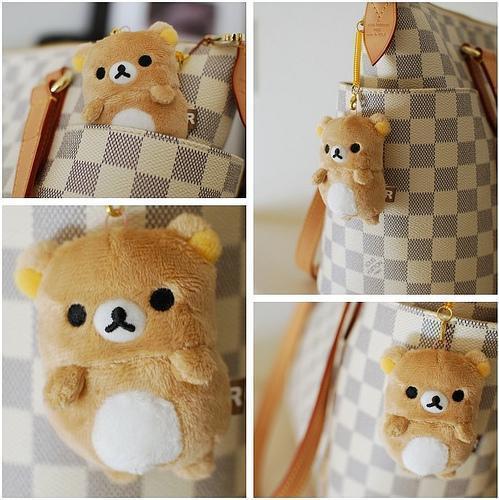How many pictures are joined?
Give a very brief answer. 4. How many teddy bears are there?
Give a very brief answer. 4. How many handbags are visible?
Give a very brief answer. 3. How many people are wearing black t-shirts?
Give a very brief answer. 0. 